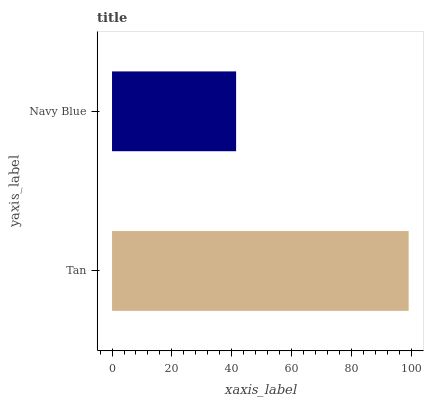Is Navy Blue the minimum?
Answer yes or no. Yes. Is Tan the maximum?
Answer yes or no. Yes. Is Navy Blue the maximum?
Answer yes or no. No. Is Tan greater than Navy Blue?
Answer yes or no. Yes. Is Navy Blue less than Tan?
Answer yes or no. Yes. Is Navy Blue greater than Tan?
Answer yes or no. No. Is Tan less than Navy Blue?
Answer yes or no. No. Is Tan the high median?
Answer yes or no. Yes. Is Navy Blue the low median?
Answer yes or no. Yes. Is Navy Blue the high median?
Answer yes or no. No. Is Tan the low median?
Answer yes or no. No. 